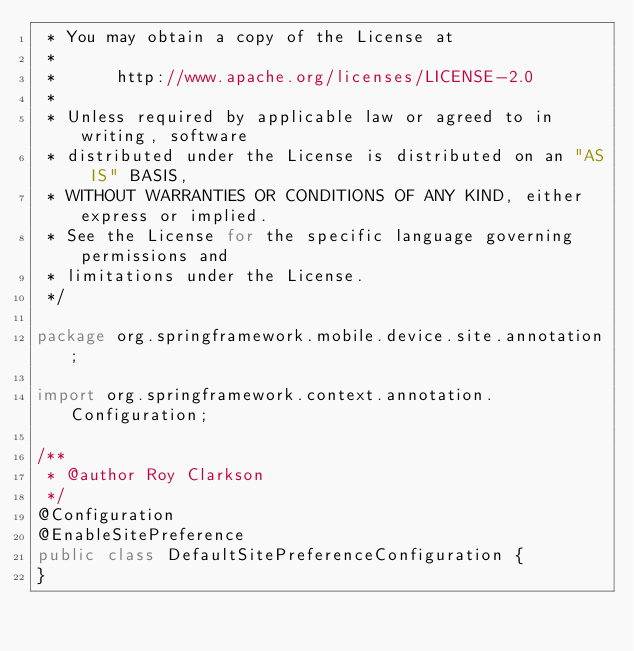<code> <loc_0><loc_0><loc_500><loc_500><_Java_> * You may obtain a copy of the License at
 *
 *      http://www.apache.org/licenses/LICENSE-2.0
 *
 * Unless required by applicable law or agreed to in writing, software
 * distributed under the License is distributed on an "AS IS" BASIS,
 * WITHOUT WARRANTIES OR CONDITIONS OF ANY KIND, either express or implied.
 * See the License for the specific language governing permissions and
 * limitations under the License.
 */

package org.springframework.mobile.device.site.annotation;

import org.springframework.context.annotation.Configuration;

/**
 * @author Roy Clarkson
 */
@Configuration
@EnableSitePreference
public class DefaultSitePreferenceConfiguration {
}
</code> 